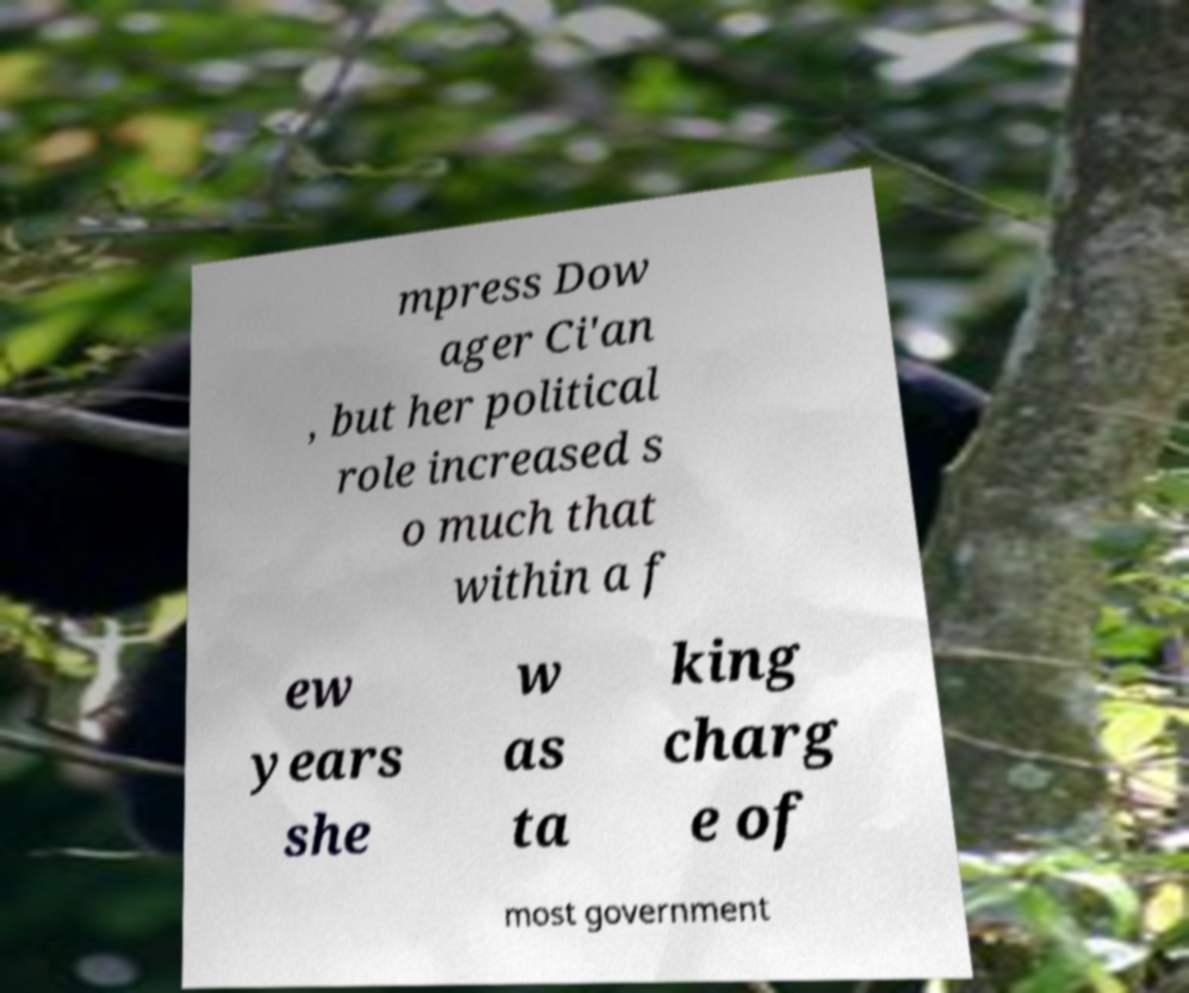I need the written content from this picture converted into text. Can you do that? mpress Dow ager Ci'an , but her political role increased s o much that within a f ew years she w as ta king charg e of most government 